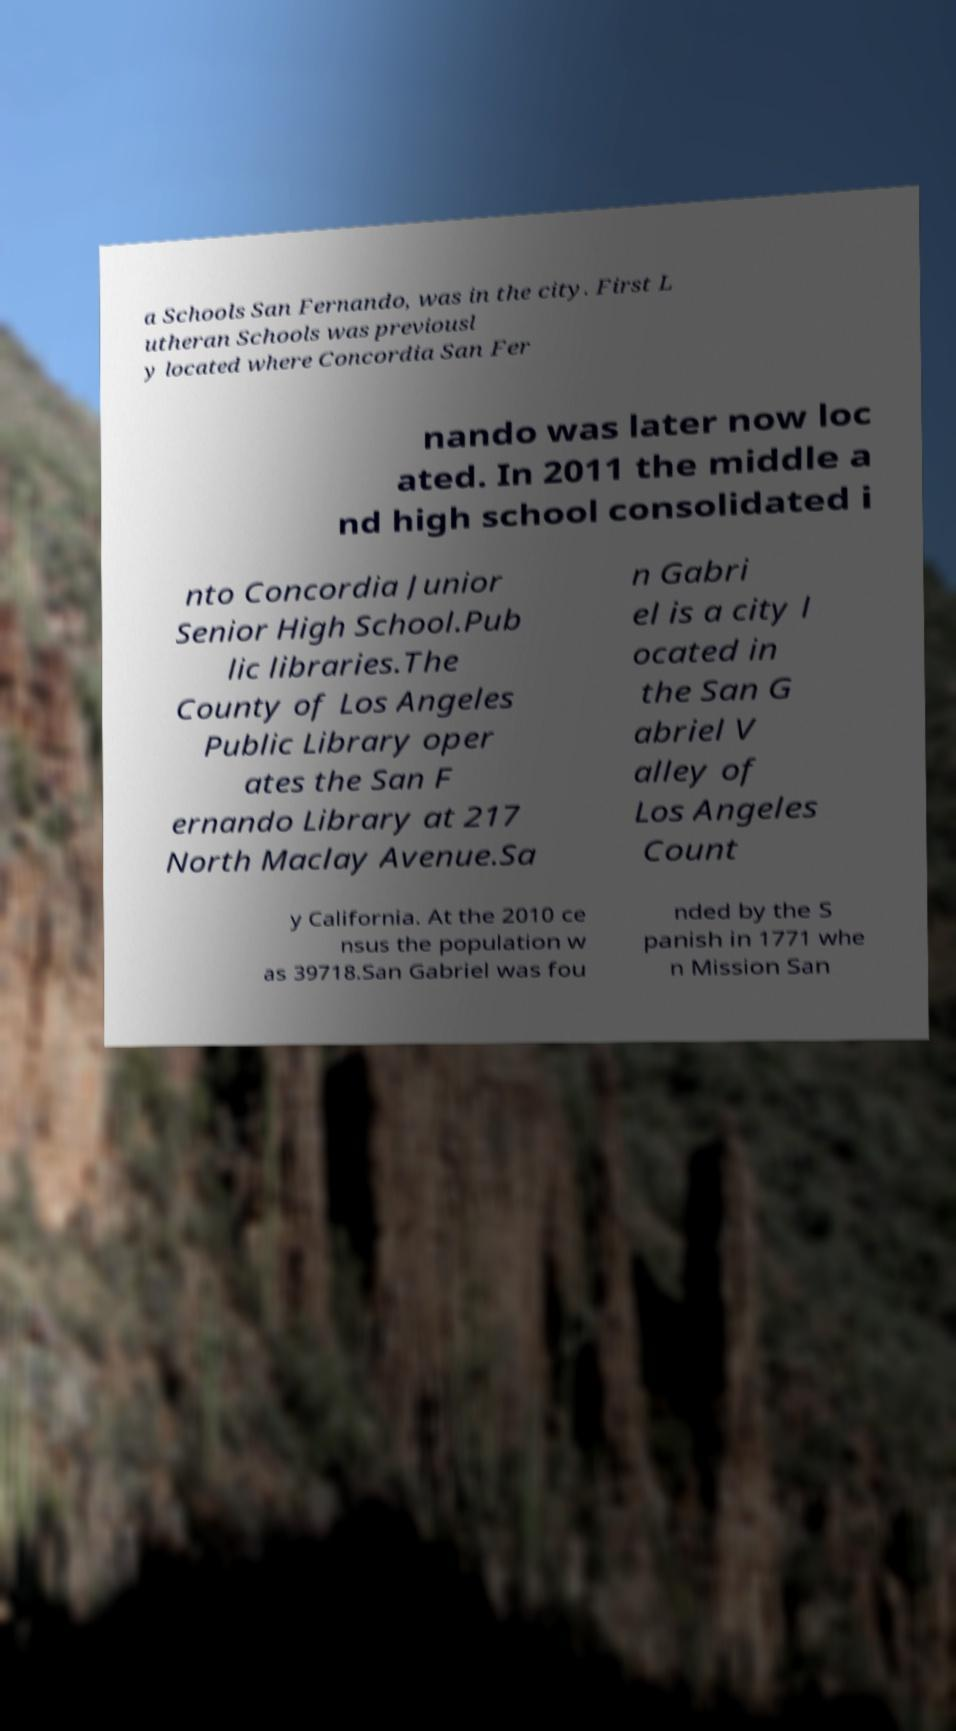Please read and relay the text visible in this image. What does it say? a Schools San Fernando, was in the city. First L utheran Schools was previousl y located where Concordia San Fer nando was later now loc ated. In 2011 the middle a nd high school consolidated i nto Concordia Junior Senior High School.Pub lic libraries.The County of Los Angeles Public Library oper ates the San F ernando Library at 217 North Maclay Avenue.Sa n Gabri el is a city l ocated in the San G abriel V alley of Los Angeles Count y California. At the 2010 ce nsus the population w as 39718.San Gabriel was fou nded by the S panish in 1771 whe n Mission San 